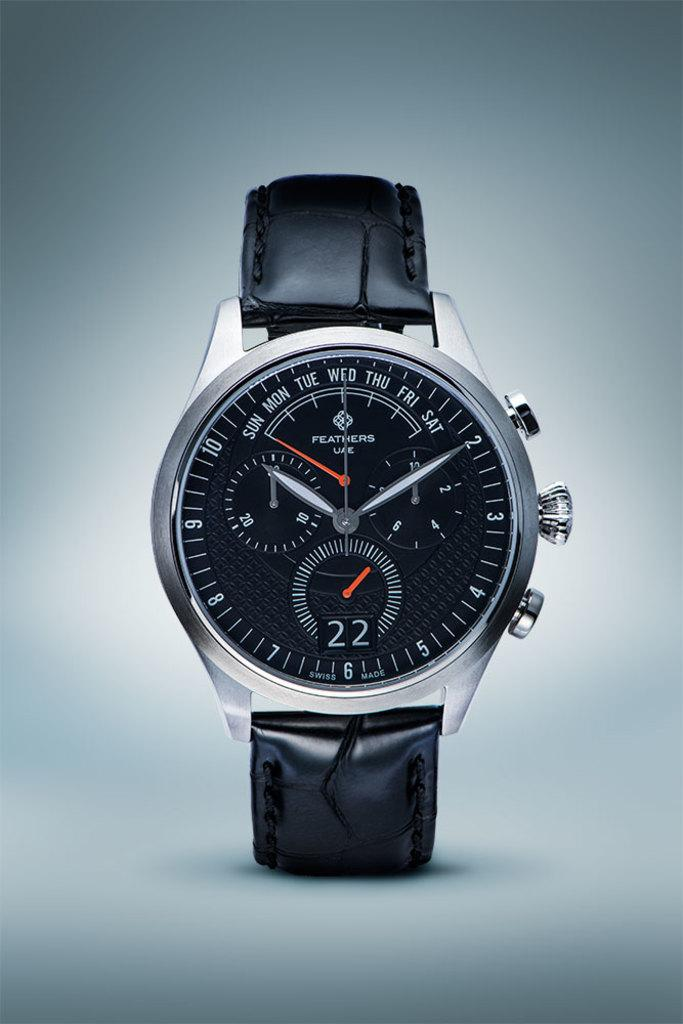<image>
Offer a succinct explanation of the picture presented. Feathers UAE silver and black watch with numbers 